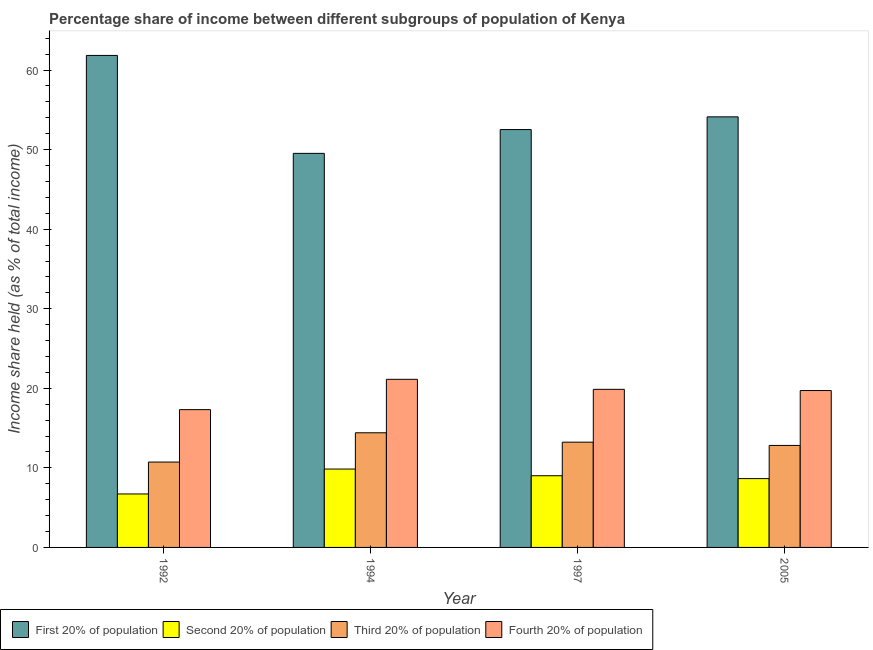How many different coloured bars are there?
Provide a succinct answer. 4. Are the number of bars on each tick of the X-axis equal?
Your answer should be very brief. Yes. How many bars are there on the 1st tick from the left?
Make the answer very short. 4. How many bars are there on the 3rd tick from the right?
Provide a short and direct response. 4. What is the share of the income held by first 20% of the population in 1997?
Ensure brevity in your answer.  52.52. Across all years, what is the maximum share of the income held by third 20% of the population?
Your answer should be compact. 14.41. Across all years, what is the minimum share of the income held by fourth 20% of the population?
Your answer should be compact. 17.32. In which year was the share of the income held by second 20% of the population maximum?
Provide a short and direct response. 1994. In which year was the share of the income held by third 20% of the population minimum?
Provide a succinct answer. 1992. What is the total share of the income held by fourth 20% of the population in the graph?
Provide a succinct answer. 78.04. What is the difference between the share of the income held by first 20% of the population in 1994 and that in 1997?
Provide a succinct answer. -2.99. What is the difference between the share of the income held by second 20% of the population in 2005 and the share of the income held by first 20% of the population in 1997?
Provide a succinct answer. -0.36. What is the average share of the income held by fourth 20% of the population per year?
Your response must be concise. 19.51. In the year 1997, what is the difference between the share of the income held by third 20% of the population and share of the income held by first 20% of the population?
Provide a short and direct response. 0. What is the ratio of the share of the income held by first 20% of the population in 1997 to that in 2005?
Give a very brief answer. 0.97. What is the difference between the highest and the second highest share of the income held by fourth 20% of the population?
Your answer should be very brief. 1.26. What is the difference between the highest and the lowest share of the income held by third 20% of the population?
Your response must be concise. 3.68. Is it the case that in every year, the sum of the share of the income held by first 20% of the population and share of the income held by third 20% of the population is greater than the sum of share of the income held by second 20% of the population and share of the income held by fourth 20% of the population?
Your answer should be compact. Yes. What does the 1st bar from the left in 1994 represents?
Your response must be concise. First 20% of population. What does the 2nd bar from the right in 1994 represents?
Your response must be concise. Third 20% of population. Is it the case that in every year, the sum of the share of the income held by first 20% of the population and share of the income held by second 20% of the population is greater than the share of the income held by third 20% of the population?
Provide a succinct answer. Yes. What is the difference between two consecutive major ticks on the Y-axis?
Your answer should be very brief. 10. Are the values on the major ticks of Y-axis written in scientific E-notation?
Ensure brevity in your answer.  No. Where does the legend appear in the graph?
Provide a succinct answer. Bottom left. How many legend labels are there?
Provide a short and direct response. 4. What is the title of the graph?
Provide a succinct answer. Percentage share of income between different subgroups of population of Kenya. Does "First 20% of population" appear as one of the legend labels in the graph?
Offer a terse response. Yes. What is the label or title of the X-axis?
Offer a terse response. Year. What is the label or title of the Y-axis?
Ensure brevity in your answer.  Income share held (as % of total income). What is the Income share held (as % of total income) in First 20% of population in 1992?
Your answer should be compact. 61.84. What is the Income share held (as % of total income) of Second 20% of population in 1992?
Your answer should be compact. 6.72. What is the Income share held (as % of total income) in Third 20% of population in 1992?
Your response must be concise. 10.73. What is the Income share held (as % of total income) in Fourth 20% of population in 1992?
Your answer should be compact. 17.32. What is the Income share held (as % of total income) of First 20% of population in 1994?
Your response must be concise. 49.53. What is the Income share held (as % of total income) in Second 20% of population in 1994?
Provide a short and direct response. 9.85. What is the Income share held (as % of total income) of Third 20% of population in 1994?
Offer a terse response. 14.41. What is the Income share held (as % of total income) of Fourth 20% of population in 1994?
Ensure brevity in your answer.  21.13. What is the Income share held (as % of total income) of First 20% of population in 1997?
Offer a terse response. 52.52. What is the Income share held (as % of total income) of Second 20% of population in 1997?
Give a very brief answer. 9.01. What is the Income share held (as % of total income) of Third 20% of population in 1997?
Your answer should be very brief. 13.23. What is the Income share held (as % of total income) in Fourth 20% of population in 1997?
Give a very brief answer. 19.87. What is the Income share held (as % of total income) of First 20% of population in 2005?
Your answer should be very brief. 54.12. What is the Income share held (as % of total income) of Second 20% of population in 2005?
Ensure brevity in your answer.  8.65. What is the Income share held (as % of total income) in Third 20% of population in 2005?
Keep it short and to the point. 12.82. What is the Income share held (as % of total income) in Fourth 20% of population in 2005?
Offer a terse response. 19.72. Across all years, what is the maximum Income share held (as % of total income) in First 20% of population?
Your answer should be compact. 61.84. Across all years, what is the maximum Income share held (as % of total income) of Second 20% of population?
Ensure brevity in your answer.  9.85. Across all years, what is the maximum Income share held (as % of total income) in Third 20% of population?
Provide a succinct answer. 14.41. Across all years, what is the maximum Income share held (as % of total income) of Fourth 20% of population?
Make the answer very short. 21.13. Across all years, what is the minimum Income share held (as % of total income) in First 20% of population?
Your answer should be very brief. 49.53. Across all years, what is the minimum Income share held (as % of total income) of Second 20% of population?
Provide a succinct answer. 6.72. Across all years, what is the minimum Income share held (as % of total income) of Third 20% of population?
Your answer should be very brief. 10.73. Across all years, what is the minimum Income share held (as % of total income) in Fourth 20% of population?
Make the answer very short. 17.32. What is the total Income share held (as % of total income) in First 20% of population in the graph?
Provide a succinct answer. 218.01. What is the total Income share held (as % of total income) of Second 20% of population in the graph?
Offer a terse response. 34.23. What is the total Income share held (as % of total income) in Third 20% of population in the graph?
Provide a succinct answer. 51.19. What is the total Income share held (as % of total income) of Fourth 20% of population in the graph?
Your answer should be compact. 78.04. What is the difference between the Income share held (as % of total income) in First 20% of population in 1992 and that in 1994?
Your response must be concise. 12.31. What is the difference between the Income share held (as % of total income) of Second 20% of population in 1992 and that in 1994?
Give a very brief answer. -3.13. What is the difference between the Income share held (as % of total income) in Third 20% of population in 1992 and that in 1994?
Provide a short and direct response. -3.68. What is the difference between the Income share held (as % of total income) of Fourth 20% of population in 1992 and that in 1994?
Keep it short and to the point. -3.81. What is the difference between the Income share held (as % of total income) of First 20% of population in 1992 and that in 1997?
Provide a succinct answer. 9.32. What is the difference between the Income share held (as % of total income) in Second 20% of population in 1992 and that in 1997?
Offer a terse response. -2.29. What is the difference between the Income share held (as % of total income) in Fourth 20% of population in 1992 and that in 1997?
Provide a short and direct response. -2.55. What is the difference between the Income share held (as % of total income) in First 20% of population in 1992 and that in 2005?
Provide a short and direct response. 7.72. What is the difference between the Income share held (as % of total income) in Second 20% of population in 1992 and that in 2005?
Your answer should be very brief. -1.93. What is the difference between the Income share held (as % of total income) in Third 20% of population in 1992 and that in 2005?
Keep it short and to the point. -2.09. What is the difference between the Income share held (as % of total income) of Fourth 20% of population in 1992 and that in 2005?
Your response must be concise. -2.4. What is the difference between the Income share held (as % of total income) in First 20% of population in 1994 and that in 1997?
Your answer should be compact. -2.99. What is the difference between the Income share held (as % of total income) of Second 20% of population in 1994 and that in 1997?
Your response must be concise. 0.84. What is the difference between the Income share held (as % of total income) in Third 20% of population in 1994 and that in 1997?
Your answer should be compact. 1.18. What is the difference between the Income share held (as % of total income) of Fourth 20% of population in 1994 and that in 1997?
Offer a very short reply. 1.26. What is the difference between the Income share held (as % of total income) of First 20% of population in 1994 and that in 2005?
Give a very brief answer. -4.59. What is the difference between the Income share held (as % of total income) of Second 20% of population in 1994 and that in 2005?
Offer a very short reply. 1.2. What is the difference between the Income share held (as % of total income) of Third 20% of population in 1994 and that in 2005?
Ensure brevity in your answer.  1.59. What is the difference between the Income share held (as % of total income) of Fourth 20% of population in 1994 and that in 2005?
Make the answer very short. 1.41. What is the difference between the Income share held (as % of total income) of First 20% of population in 1997 and that in 2005?
Offer a very short reply. -1.6. What is the difference between the Income share held (as % of total income) in Second 20% of population in 1997 and that in 2005?
Provide a short and direct response. 0.36. What is the difference between the Income share held (as % of total income) of Third 20% of population in 1997 and that in 2005?
Offer a very short reply. 0.41. What is the difference between the Income share held (as % of total income) of First 20% of population in 1992 and the Income share held (as % of total income) of Second 20% of population in 1994?
Your response must be concise. 51.99. What is the difference between the Income share held (as % of total income) in First 20% of population in 1992 and the Income share held (as % of total income) in Third 20% of population in 1994?
Provide a short and direct response. 47.43. What is the difference between the Income share held (as % of total income) of First 20% of population in 1992 and the Income share held (as % of total income) of Fourth 20% of population in 1994?
Your answer should be very brief. 40.71. What is the difference between the Income share held (as % of total income) in Second 20% of population in 1992 and the Income share held (as % of total income) in Third 20% of population in 1994?
Offer a terse response. -7.69. What is the difference between the Income share held (as % of total income) in Second 20% of population in 1992 and the Income share held (as % of total income) in Fourth 20% of population in 1994?
Make the answer very short. -14.41. What is the difference between the Income share held (as % of total income) of Third 20% of population in 1992 and the Income share held (as % of total income) of Fourth 20% of population in 1994?
Make the answer very short. -10.4. What is the difference between the Income share held (as % of total income) in First 20% of population in 1992 and the Income share held (as % of total income) in Second 20% of population in 1997?
Your answer should be very brief. 52.83. What is the difference between the Income share held (as % of total income) of First 20% of population in 1992 and the Income share held (as % of total income) of Third 20% of population in 1997?
Provide a short and direct response. 48.61. What is the difference between the Income share held (as % of total income) in First 20% of population in 1992 and the Income share held (as % of total income) in Fourth 20% of population in 1997?
Your answer should be compact. 41.97. What is the difference between the Income share held (as % of total income) in Second 20% of population in 1992 and the Income share held (as % of total income) in Third 20% of population in 1997?
Offer a terse response. -6.51. What is the difference between the Income share held (as % of total income) in Second 20% of population in 1992 and the Income share held (as % of total income) in Fourth 20% of population in 1997?
Your response must be concise. -13.15. What is the difference between the Income share held (as % of total income) of Third 20% of population in 1992 and the Income share held (as % of total income) of Fourth 20% of population in 1997?
Offer a very short reply. -9.14. What is the difference between the Income share held (as % of total income) of First 20% of population in 1992 and the Income share held (as % of total income) of Second 20% of population in 2005?
Your response must be concise. 53.19. What is the difference between the Income share held (as % of total income) of First 20% of population in 1992 and the Income share held (as % of total income) of Third 20% of population in 2005?
Make the answer very short. 49.02. What is the difference between the Income share held (as % of total income) in First 20% of population in 1992 and the Income share held (as % of total income) in Fourth 20% of population in 2005?
Make the answer very short. 42.12. What is the difference between the Income share held (as % of total income) in Second 20% of population in 1992 and the Income share held (as % of total income) in Fourth 20% of population in 2005?
Provide a short and direct response. -13. What is the difference between the Income share held (as % of total income) in Third 20% of population in 1992 and the Income share held (as % of total income) in Fourth 20% of population in 2005?
Keep it short and to the point. -8.99. What is the difference between the Income share held (as % of total income) of First 20% of population in 1994 and the Income share held (as % of total income) of Second 20% of population in 1997?
Offer a very short reply. 40.52. What is the difference between the Income share held (as % of total income) of First 20% of population in 1994 and the Income share held (as % of total income) of Third 20% of population in 1997?
Give a very brief answer. 36.3. What is the difference between the Income share held (as % of total income) of First 20% of population in 1994 and the Income share held (as % of total income) of Fourth 20% of population in 1997?
Keep it short and to the point. 29.66. What is the difference between the Income share held (as % of total income) in Second 20% of population in 1994 and the Income share held (as % of total income) in Third 20% of population in 1997?
Your answer should be compact. -3.38. What is the difference between the Income share held (as % of total income) of Second 20% of population in 1994 and the Income share held (as % of total income) of Fourth 20% of population in 1997?
Provide a succinct answer. -10.02. What is the difference between the Income share held (as % of total income) of Third 20% of population in 1994 and the Income share held (as % of total income) of Fourth 20% of population in 1997?
Offer a very short reply. -5.46. What is the difference between the Income share held (as % of total income) in First 20% of population in 1994 and the Income share held (as % of total income) in Second 20% of population in 2005?
Provide a succinct answer. 40.88. What is the difference between the Income share held (as % of total income) in First 20% of population in 1994 and the Income share held (as % of total income) in Third 20% of population in 2005?
Offer a very short reply. 36.71. What is the difference between the Income share held (as % of total income) of First 20% of population in 1994 and the Income share held (as % of total income) of Fourth 20% of population in 2005?
Offer a terse response. 29.81. What is the difference between the Income share held (as % of total income) of Second 20% of population in 1994 and the Income share held (as % of total income) of Third 20% of population in 2005?
Ensure brevity in your answer.  -2.97. What is the difference between the Income share held (as % of total income) of Second 20% of population in 1994 and the Income share held (as % of total income) of Fourth 20% of population in 2005?
Your response must be concise. -9.87. What is the difference between the Income share held (as % of total income) in Third 20% of population in 1994 and the Income share held (as % of total income) in Fourth 20% of population in 2005?
Offer a very short reply. -5.31. What is the difference between the Income share held (as % of total income) in First 20% of population in 1997 and the Income share held (as % of total income) in Second 20% of population in 2005?
Provide a short and direct response. 43.87. What is the difference between the Income share held (as % of total income) in First 20% of population in 1997 and the Income share held (as % of total income) in Third 20% of population in 2005?
Keep it short and to the point. 39.7. What is the difference between the Income share held (as % of total income) of First 20% of population in 1997 and the Income share held (as % of total income) of Fourth 20% of population in 2005?
Offer a very short reply. 32.8. What is the difference between the Income share held (as % of total income) of Second 20% of population in 1997 and the Income share held (as % of total income) of Third 20% of population in 2005?
Your answer should be very brief. -3.81. What is the difference between the Income share held (as % of total income) of Second 20% of population in 1997 and the Income share held (as % of total income) of Fourth 20% of population in 2005?
Your answer should be compact. -10.71. What is the difference between the Income share held (as % of total income) in Third 20% of population in 1997 and the Income share held (as % of total income) in Fourth 20% of population in 2005?
Offer a terse response. -6.49. What is the average Income share held (as % of total income) in First 20% of population per year?
Provide a short and direct response. 54.5. What is the average Income share held (as % of total income) in Second 20% of population per year?
Give a very brief answer. 8.56. What is the average Income share held (as % of total income) of Third 20% of population per year?
Make the answer very short. 12.8. What is the average Income share held (as % of total income) in Fourth 20% of population per year?
Your response must be concise. 19.51. In the year 1992, what is the difference between the Income share held (as % of total income) of First 20% of population and Income share held (as % of total income) of Second 20% of population?
Offer a very short reply. 55.12. In the year 1992, what is the difference between the Income share held (as % of total income) in First 20% of population and Income share held (as % of total income) in Third 20% of population?
Ensure brevity in your answer.  51.11. In the year 1992, what is the difference between the Income share held (as % of total income) in First 20% of population and Income share held (as % of total income) in Fourth 20% of population?
Make the answer very short. 44.52. In the year 1992, what is the difference between the Income share held (as % of total income) of Second 20% of population and Income share held (as % of total income) of Third 20% of population?
Keep it short and to the point. -4.01. In the year 1992, what is the difference between the Income share held (as % of total income) of Second 20% of population and Income share held (as % of total income) of Fourth 20% of population?
Your answer should be compact. -10.6. In the year 1992, what is the difference between the Income share held (as % of total income) in Third 20% of population and Income share held (as % of total income) in Fourth 20% of population?
Offer a terse response. -6.59. In the year 1994, what is the difference between the Income share held (as % of total income) of First 20% of population and Income share held (as % of total income) of Second 20% of population?
Your answer should be compact. 39.68. In the year 1994, what is the difference between the Income share held (as % of total income) of First 20% of population and Income share held (as % of total income) of Third 20% of population?
Offer a very short reply. 35.12. In the year 1994, what is the difference between the Income share held (as % of total income) in First 20% of population and Income share held (as % of total income) in Fourth 20% of population?
Give a very brief answer. 28.4. In the year 1994, what is the difference between the Income share held (as % of total income) of Second 20% of population and Income share held (as % of total income) of Third 20% of population?
Provide a short and direct response. -4.56. In the year 1994, what is the difference between the Income share held (as % of total income) of Second 20% of population and Income share held (as % of total income) of Fourth 20% of population?
Your answer should be compact. -11.28. In the year 1994, what is the difference between the Income share held (as % of total income) in Third 20% of population and Income share held (as % of total income) in Fourth 20% of population?
Provide a short and direct response. -6.72. In the year 1997, what is the difference between the Income share held (as % of total income) in First 20% of population and Income share held (as % of total income) in Second 20% of population?
Make the answer very short. 43.51. In the year 1997, what is the difference between the Income share held (as % of total income) in First 20% of population and Income share held (as % of total income) in Third 20% of population?
Provide a succinct answer. 39.29. In the year 1997, what is the difference between the Income share held (as % of total income) of First 20% of population and Income share held (as % of total income) of Fourth 20% of population?
Your answer should be very brief. 32.65. In the year 1997, what is the difference between the Income share held (as % of total income) of Second 20% of population and Income share held (as % of total income) of Third 20% of population?
Provide a short and direct response. -4.22. In the year 1997, what is the difference between the Income share held (as % of total income) in Second 20% of population and Income share held (as % of total income) in Fourth 20% of population?
Your answer should be compact. -10.86. In the year 1997, what is the difference between the Income share held (as % of total income) of Third 20% of population and Income share held (as % of total income) of Fourth 20% of population?
Keep it short and to the point. -6.64. In the year 2005, what is the difference between the Income share held (as % of total income) of First 20% of population and Income share held (as % of total income) of Second 20% of population?
Provide a short and direct response. 45.47. In the year 2005, what is the difference between the Income share held (as % of total income) of First 20% of population and Income share held (as % of total income) of Third 20% of population?
Offer a terse response. 41.3. In the year 2005, what is the difference between the Income share held (as % of total income) of First 20% of population and Income share held (as % of total income) of Fourth 20% of population?
Your response must be concise. 34.4. In the year 2005, what is the difference between the Income share held (as % of total income) of Second 20% of population and Income share held (as % of total income) of Third 20% of population?
Ensure brevity in your answer.  -4.17. In the year 2005, what is the difference between the Income share held (as % of total income) of Second 20% of population and Income share held (as % of total income) of Fourth 20% of population?
Offer a very short reply. -11.07. In the year 2005, what is the difference between the Income share held (as % of total income) of Third 20% of population and Income share held (as % of total income) of Fourth 20% of population?
Make the answer very short. -6.9. What is the ratio of the Income share held (as % of total income) of First 20% of population in 1992 to that in 1994?
Make the answer very short. 1.25. What is the ratio of the Income share held (as % of total income) of Second 20% of population in 1992 to that in 1994?
Offer a terse response. 0.68. What is the ratio of the Income share held (as % of total income) in Third 20% of population in 1992 to that in 1994?
Keep it short and to the point. 0.74. What is the ratio of the Income share held (as % of total income) of Fourth 20% of population in 1992 to that in 1994?
Keep it short and to the point. 0.82. What is the ratio of the Income share held (as % of total income) of First 20% of population in 1992 to that in 1997?
Provide a succinct answer. 1.18. What is the ratio of the Income share held (as % of total income) in Second 20% of population in 1992 to that in 1997?
Ensure brevity in your answer.  0.75. What is the ratio of the Income share held (as % of total income) of Third 20% of population in 1992 to that in 1997?
Offer a terse response. 0.81. What is the ratio of the Income share held (as % of total income) in Fourth 20% of population in 1992 to that in 1997?
Give a very brief answer. 0.87. What is the ratio of the Income share held (as % of total income) in First 20% of population in 1992 to that in 2005?
Make the answer very short. 1.14. What is the ratio of the Income share held (as % of total income) of Second 20% of population in 1992 to that in 2005?
Give a very brief answer. 0.78. What is the ratio of the Income share held (as % of total income) of Third 20% of population in 1992 to that in 2005?
Provide a succinct answer. 0.84. What is the ratio of the Income share held (as % of total income) in Fourth 20% of population in 1992 to that in 2005?
Your answer should be compact. 0.88. What is the ratio of the Income share held (as % of total income) of First 20% of population in 1994 to that in 1997?
Provide a succinct answer. 0.94. What is the ratio of the Income share held (as % of total income) in Second 20% of population in 1994 to that in 1997?
Offer a very short reply. 1.09. What is the ratio of the Income share held (as % of total income) of Third 20% of population in 1994 to that in 1997?
Provide a short and direct response. 1.09. What is the ratio of the Income share held (as % of total income) in Fourth 20% of population in 1994 to that in 1997?
Your response must be concise. 1.06. What is the ratio of the Income share held (as % of total income) in First 20% of population in 1994 to that in 2005?
Make the answer very short. 0.92. What is the ratio of the Income share held (as % of total income) of Second 20% of population in 1994 to that in 2005?
Keep it short and to the point. 1.14. What is the ratio of the Income share held (as % of total income) in Third 20% of population in 1994 to that in 2005?
Make the answer very short. 1.12. What is the ratio of the Income share held (as % of total income) in Fourth 20% of population in 1994 to that in 2005?
Your answer should be very brief. 1.07. What is the ratio of the Income share held (as % of total income) of First 20% of population in 1997 to that in 2005?
Your response must be concise. 0.97. What is the ratio of the Income share held (as % of total income) in Second 20% of population in 1997 to that in 2005?
Your answer should be compact. 1.04. What is the ratio of the Income share held (as % of total income) of Third 20% of population in 1997 to that in 2005?
Provide a short and direct response. 1.03. What is the ratio of the Income share held (as % of total income) in Fourth 20% of population in 1997 to that in 2005?
Give a very brief answer. 1.01. What is the difference between the highest and the second highest Income share held (as % of total income) in First 20% of population?
Your answer should be compact. 7.72. What is the difference between the highest and the second highest Income share held (as % of total income) of Second 20% of population?
Make the answer very short. 0.84. What is the difference between the highest and the second highest Income share held (as % of total income) in Third 20% of population?
Make the answer very short. 1.18. What is the difference between the highest and the second highest Income share held (as % of total income) in Fourth 20% of population?
Provide a short and direct response. 1.26. What is the difference between the highest and the lowest Income share held (as % of total income) of First 20% of population?
Offer a terse response. 12.31. What is the difference between the highest and the lowest Income share held (as % of total income) of Second 20% of population?
Your answer should be compact. 3.13. What is the difference between the highest and the lowest Income share held (as % of total income) in Third 20% of population?
Ensure brevity in your answer.  3.68. What is the difference between the highest and the lowest Income share held (as % of total income) of Fourth 20% of population?
Ensure brevity in your answer.  3.81. 